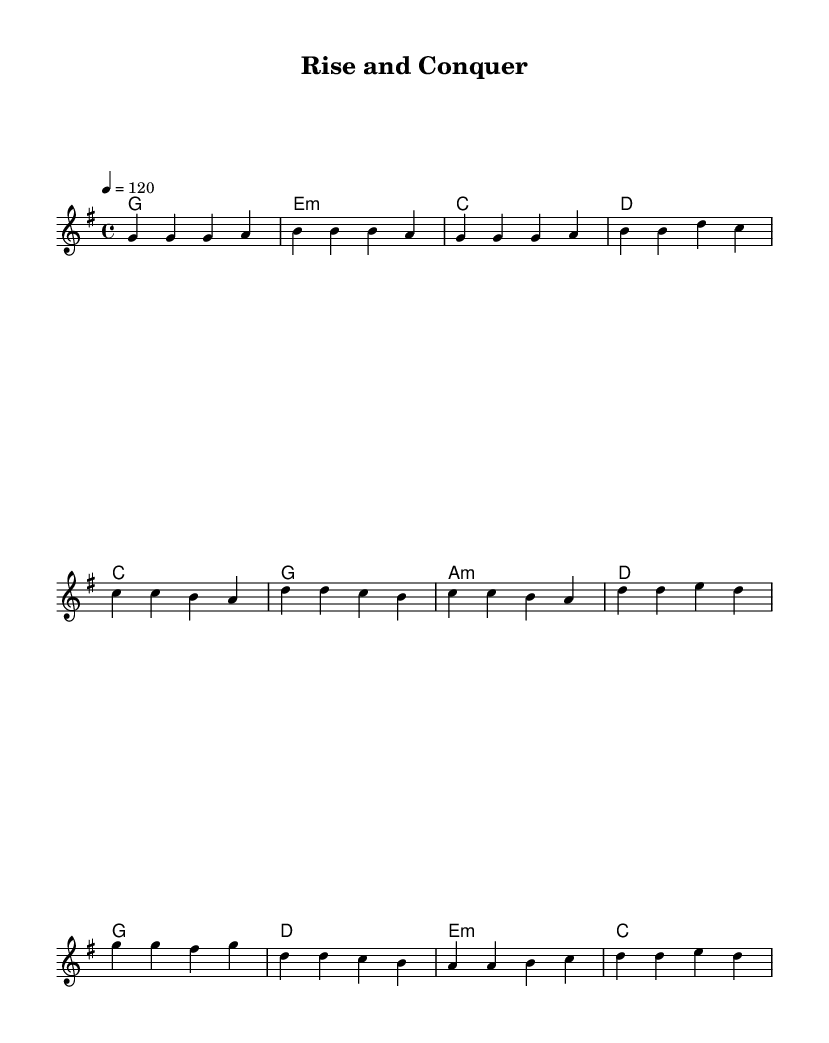What is the key signature of this music? The key signature is G major, which has one sharp (F#). You can identify the key signature at the beginning of the sheet music, where it indicates G major.
Answer: G major What is the time signature of this piece? The time signature is 4/4, as represented at the beginning of the sheet music. This means there are four beats in each measure and a quarter note receives one beat.
Answer: 4/4 What is the tempo marking indicated in the score? The tempo marking is 120 beats per minute, which is specified within the score indicating how fast the music should be played.
Answer: 120 How many measures are present in the verse section? The verse section consists of 4 measures, as you can count the vertical bar lines that divide the musical phrases into measures.
Answer: 4 What are the primary emotions conveyed in the lyrics of the chorus? The chorus communicates feelings of empowerment and determination. Phrases like "I'll rise and conquer" and "nothing can stop me now" illustrate a motivational and triumphant tone.
Answer: Empowerment Which chord progression is used in the pre-chorus? The chord progression in the pre-chorus is C, G, A minor, D. To find this, refer to the harmonic section of the score that follows the melody, where the chords are indicated above specific lyrics.
Answer: C, G, A minor, D What is the primary theme of the song? The primary theme of the song revolves around personal growth and motivation, focused on success and overcoming obstacles, reflected in the lyrics and structure of the music.
Answer: Personal growth and motivation 